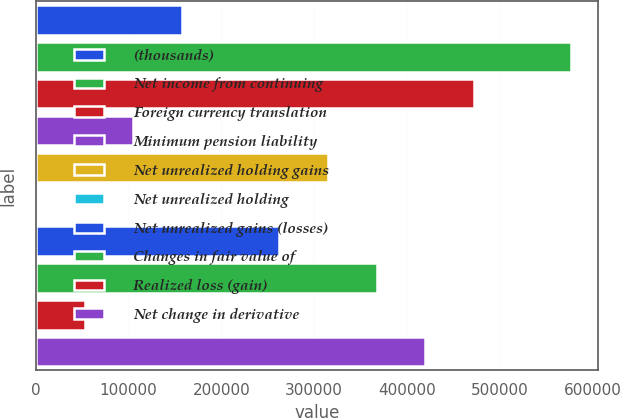Convert chart. <chart><loc_0><loc_0><loc_500><loc_500><bar_chart><fcel>(thousands)<fcel>Net income from continuing<fcel>Foreign currency translation<fcel>Minimum pension liability<fcel>Net unrealized holding gains<fcel>Net unrealized holding<fcel>Net unrealized gains (losses)<fcel>Changes in fair value of<fcel>Realized loss (gain)<fcel>Net change in derivative<nl><fcel>157521<fcel>577084<fcel>472194<fcel>105076<fcel>314857<fcel>185<fcel>262412<fcel>367303<fcel>52630.4<fcel>419748<nl></chart> 